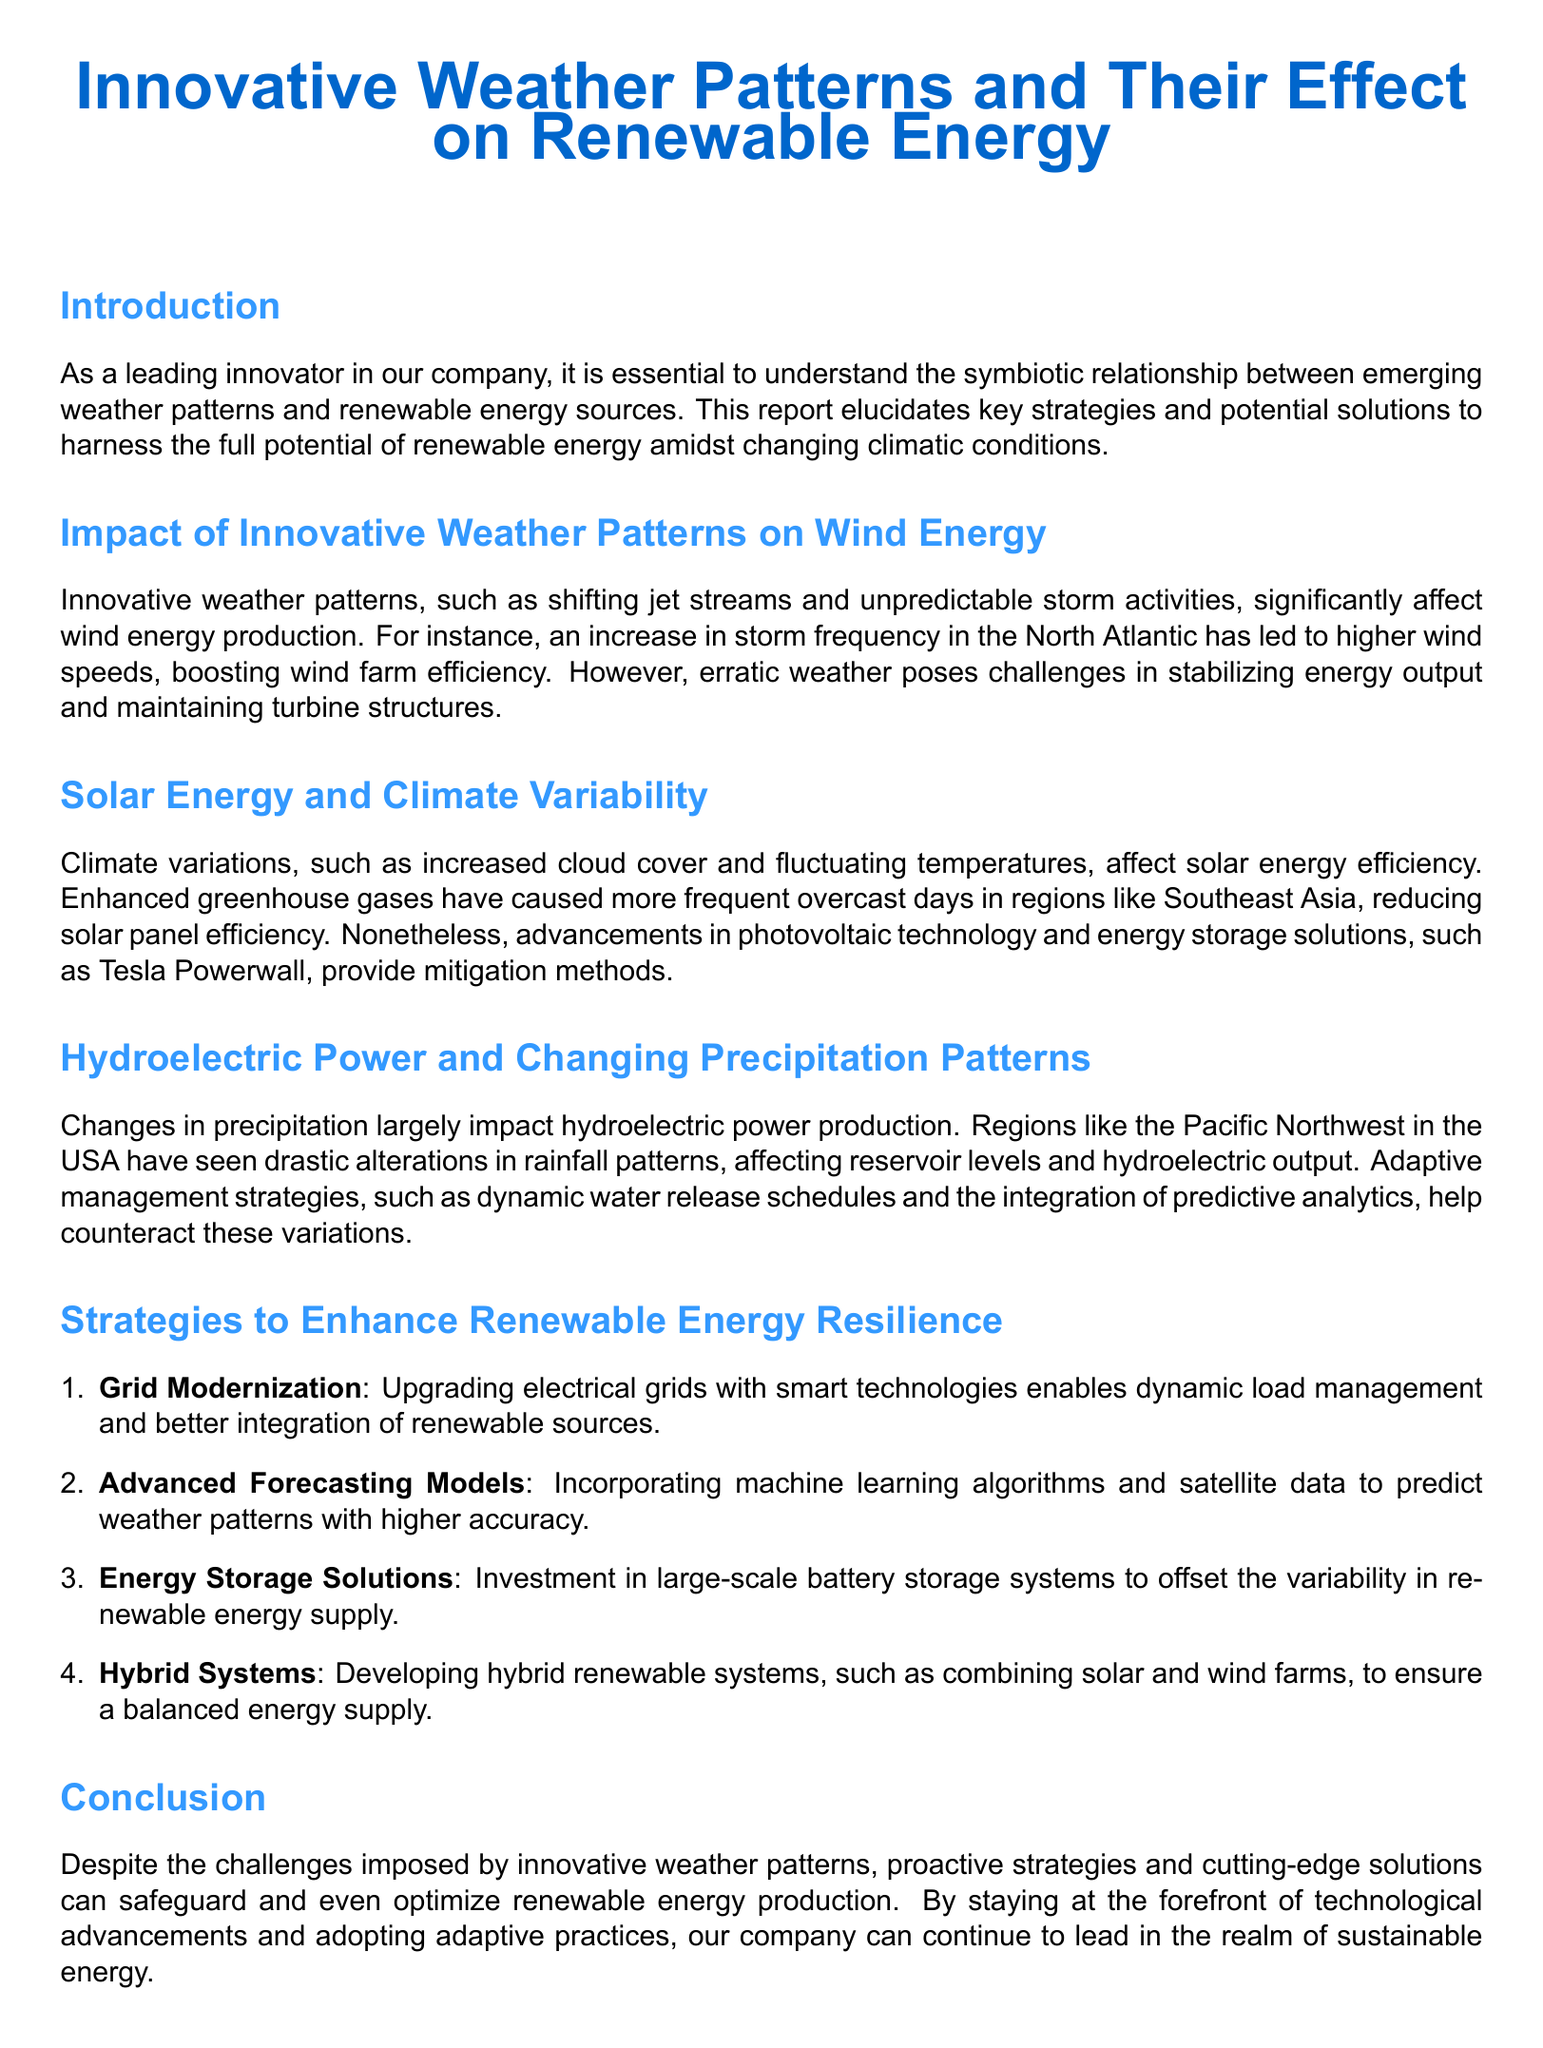What is the main focus of the report? The report focuses on the relationship between innovative weather patterns and renewable energy sources.
Answer: renewable energy Which renewable energy source is affected by shifting jet streams? The section discusses the impact of shifting jet streams specifically on wind energy production.
Answer: Wind energy What technology helps mitigate solar panel efficiency issues? The report mentions the Tesla Powerwall as a solution for solar energy efficiency reduction due to climate variations.
Answer: Tesla Powerwall Which region is mentioned as experiencing altered rainfall patterns affecting hydroelectric power? The Pacific Northwest is highlighted for its drastic alterations in rainfall patterns impacting hydroelectric output.
Answer: Pacific Northwest What is one strategy suggested for enhancing renewable energy resilience? The report lists grid modernization as a strategy for improving resilience in renewable energy systems.
Answer: Grid Modernization How does the report suggest improving the accuracy of weather predictions? It suggests incorporating machine learning algorithms and satellite data for more accurate predictions.
Answer: Machine learning algorithms Which renewable energy forms can be combined in hybrid systems? The document discusses combining solar and wind farms as part of developing hybrid renewable systems.
Answer: Solar and wind What type of report is this? It is a weather report discussing innovative weather patterns and their effects on renewable energy.
Answer: Weather report What effect has greenhouse gases had on solar energy? The report states that greenhouse gases have caused more frequent overcast days, reducing efficiency.
Answer: Reduced efficiency 